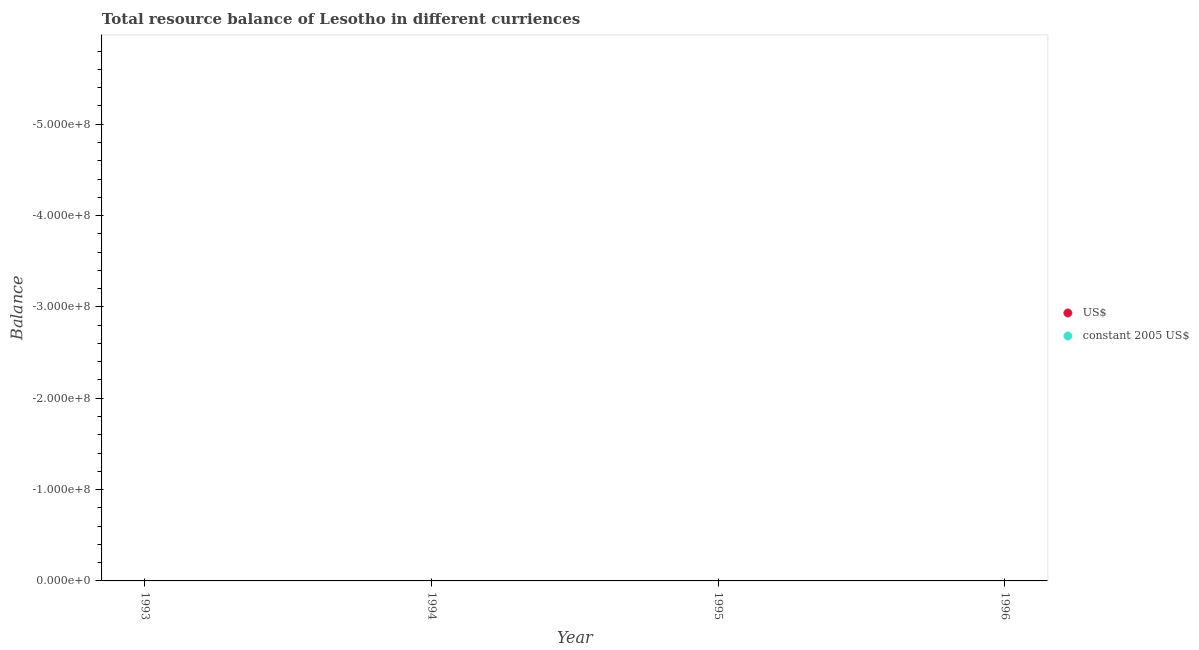How many different coloured dotlines are there?
Provide a short and direct response. 0. Is the number of dotlines equal to the number of legend labels?
Give a very brief answer. No. What is the resource balance in us$ in 1995?
Your answer should be very brief. 0. Across all years, what is the minimum resource balance in us$?
Provide a short and direct response. 0. What is the total resource balance in us$ in the graph?
Your response must be concise. 0. What is the difference between the resource balance in constant us$ in 1994 and the resource balance in us$ in 1993?
Offer a very short reply. 0. What is the average resource balance in constant us$ per year?
Your answer should be very brief. 0. Does the resource balance in constant us$ monotonically increase over the years?
Provide a succinct answer. No. How many years are there in the graph?
Your answer should be very brief. 4. Where does the legend appear in the graph?
Give a very brief answer. Center right. What is the title of the graph?
Your answer should be compact. Total resource balance of Lesotho in different curriences. Does "Under five" appear as one of the legend labels in the graph?
Your answer should be compact. No. What is the label or title of the X-axis?
Offer a very short reply. Year. What is the label or title of the Y-axis?
Your answer should be very brief. Balance. What is the Balance in US$ in 1993?
Provide a short and direct response. 0. What is the Balance of constant 2005 US$ in 1993?
Your answer should be very brief. 0. What is the Balance in US$ in 1994?
Provide a short and direct response. 0. What is the Balance in constant 2005 US$ in 1994?
Provide a short and direct response. 0. What is the Balance in US$ in 1995?
Make the answer very short. 0. What is the total Balance of US$ in the graph?
Provide a succinct answer. 0. What is the average Balance of US$ per year?
Your answer should be very brief. 0. What is the average Balance of constant 2005 US$ per year?
Offer a terse response. 0. 